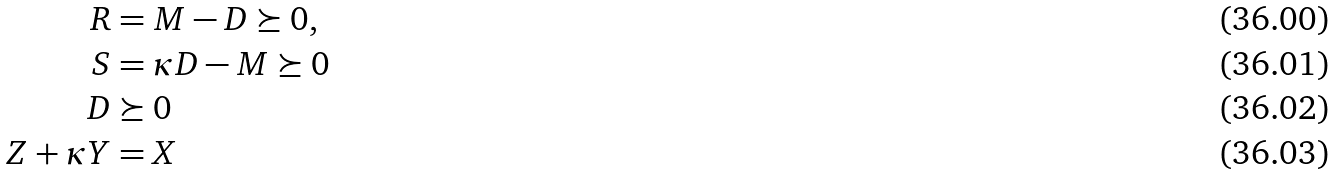Convert formula to latex. <formula><loc_0><loc_0><loc_500><loc_500>R & = M - D \succeq 0 , \\ S & = \kappa D - M \succeq 0 \\ D & \succeq 0 \\ Z + \kappa Y & = X</formula> 